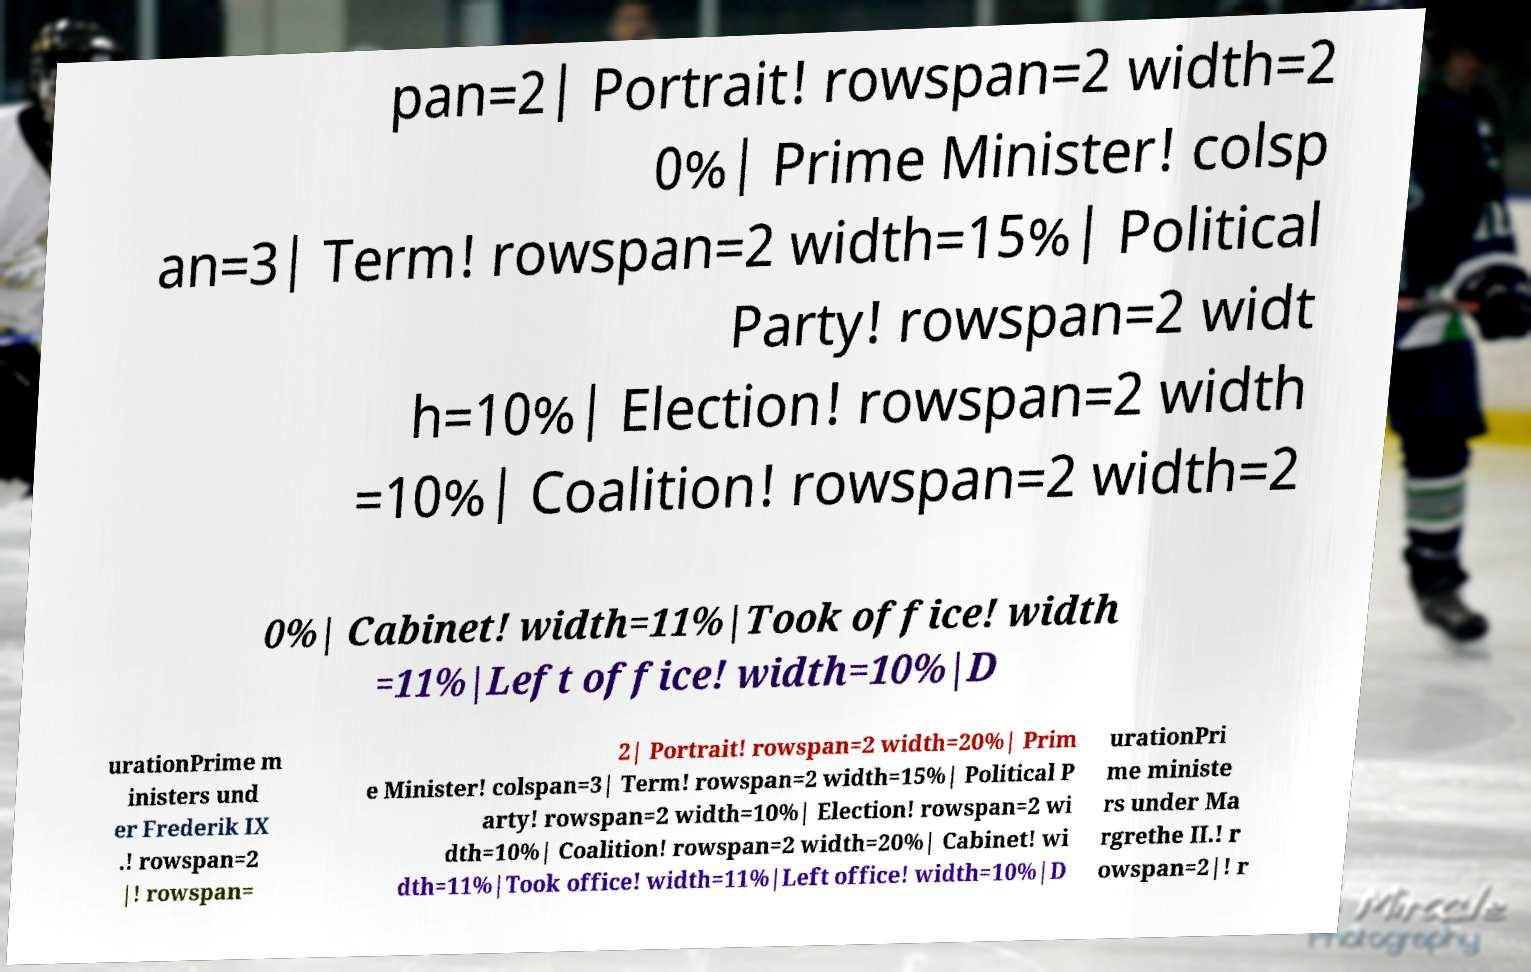I need the written content from this picture converted into text. Can you do that? pan=2| Portrait! rowspan=2 width=2 0%| Prime Minister! colsp an=3| Term! rowspan=2 width=15%| Political Party! rowspan=2 widt h=10%| Election! rowspan=2 width =10%| Coalition! rowspan=2 width=2 0%| Cabinet! width=11%|Took office! width =11%|Left office! width=10%|D urationPrime m inisters und er Frederik IX .! rowspan=2 |! rowspan= 2| Portrait! rowspan=2 width=20%| Prim e Minister! colspan=3| Term! rowspan=2 width=15%| Political P arty! rowspan=2 width=10%| Election! rowspan=2 wi dth=10%| Coalition! rowspan=2 width=20%| Cabinet! wi dth=11%|Took office! width=11%|Left office! width=10%|D urationPri me ministe rs under Ma rgrethe II.! r owspan=2|! r 